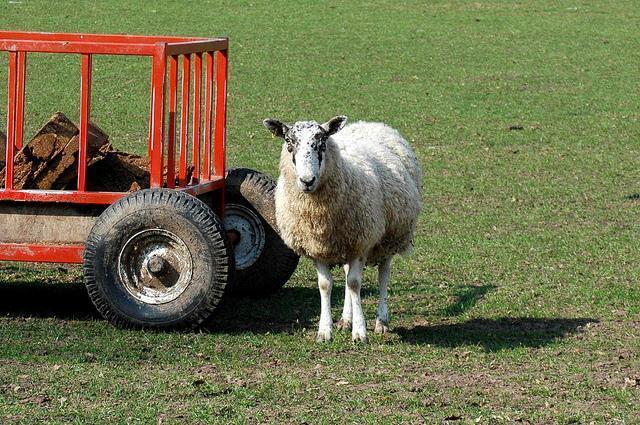How many people are in the mirror?
Give a very brief answer. 0. 